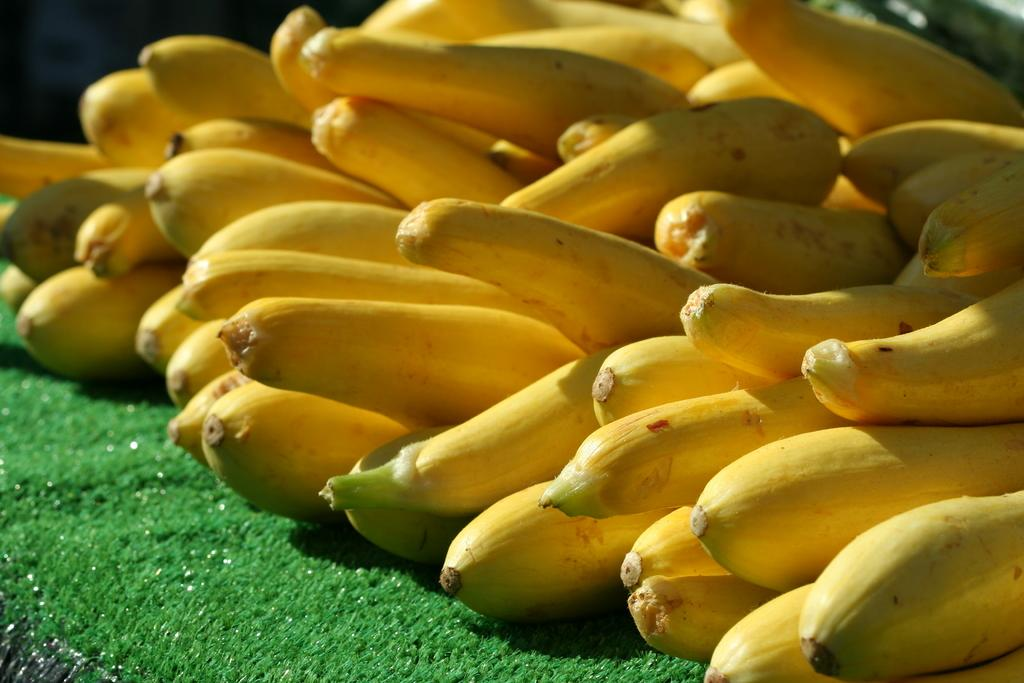What is located in the center of the image? There are fruits in the center of the image. What type of natural environment is visible in the image? There is grass on the ground in the image. What type of emotion does the fruit express towards the visitor in the image? There is no visitor present in the image, and fruits do not express emotions. 